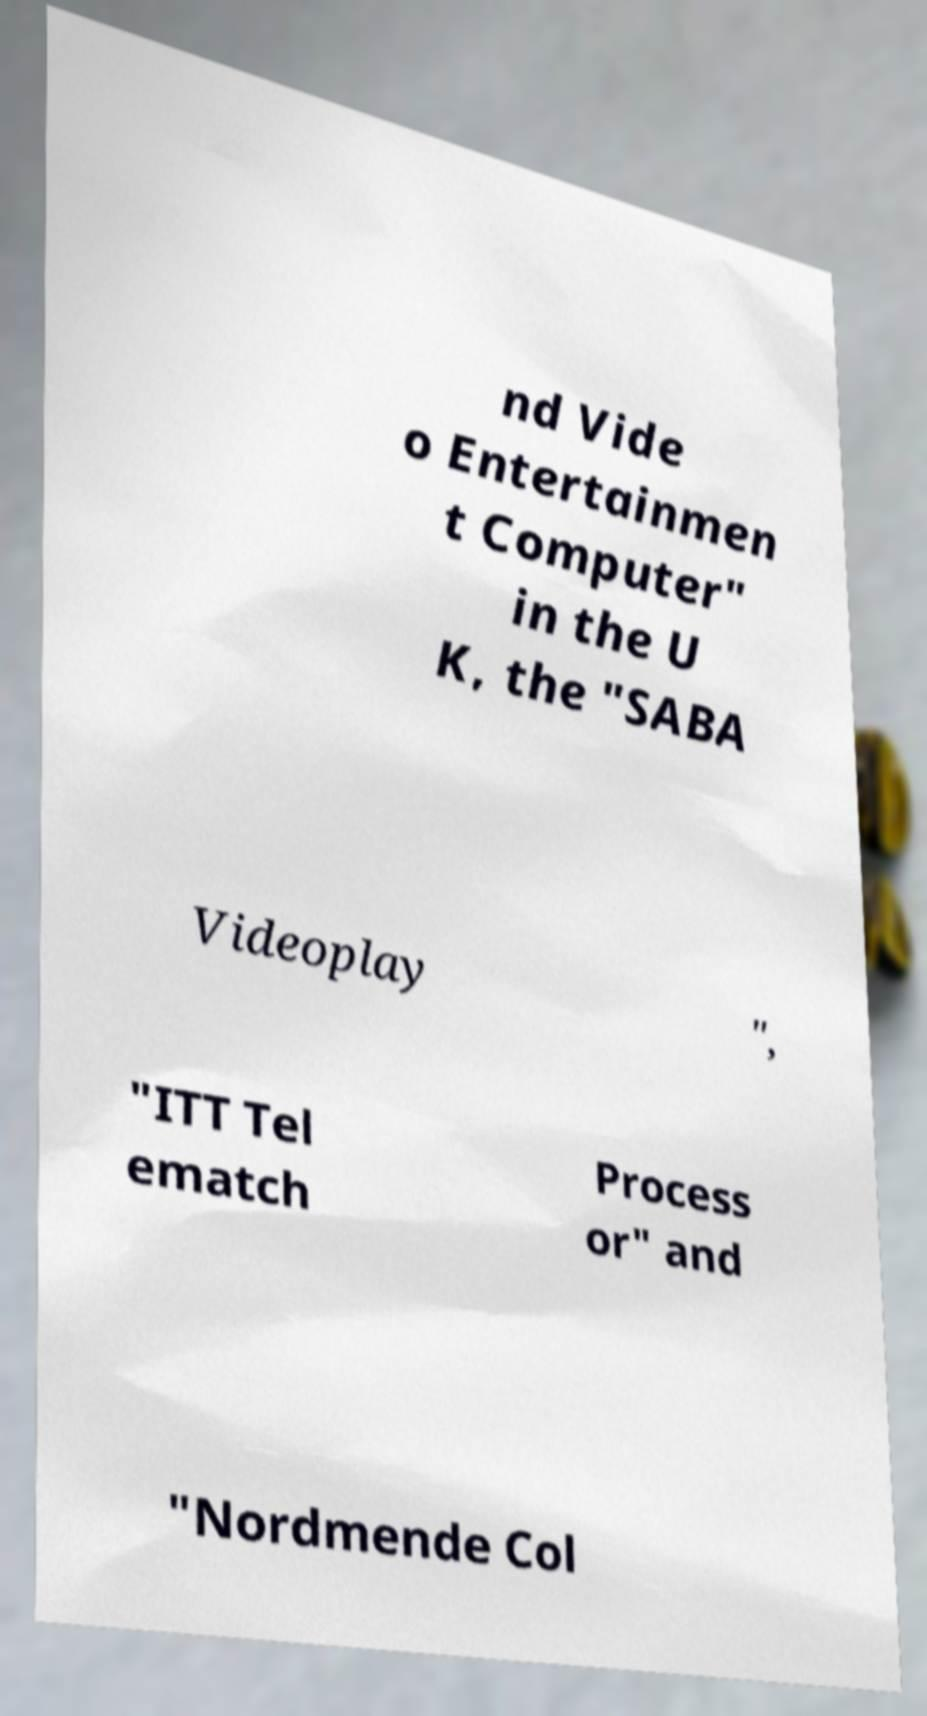Could you extract and type out the text from this image? nd Vide o Entertainmen t Computer" in the U K, the "SABA Videoplay ", "ITT Tel ematch Process or" and "Nordmende Col 